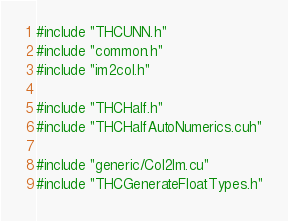<code> <loc_0><loc_0><loc_500><loc_500><_Cuda_>#include "THCUNN.h"
#include "common.h"
#include "im2col.h"

#include "THCHalf.h"
#include "THCHalfAutoNumerics.cuh"

#include "generic/Col2Im.cu"
#include "THCGenerateFloatTypes.h"
</code> 